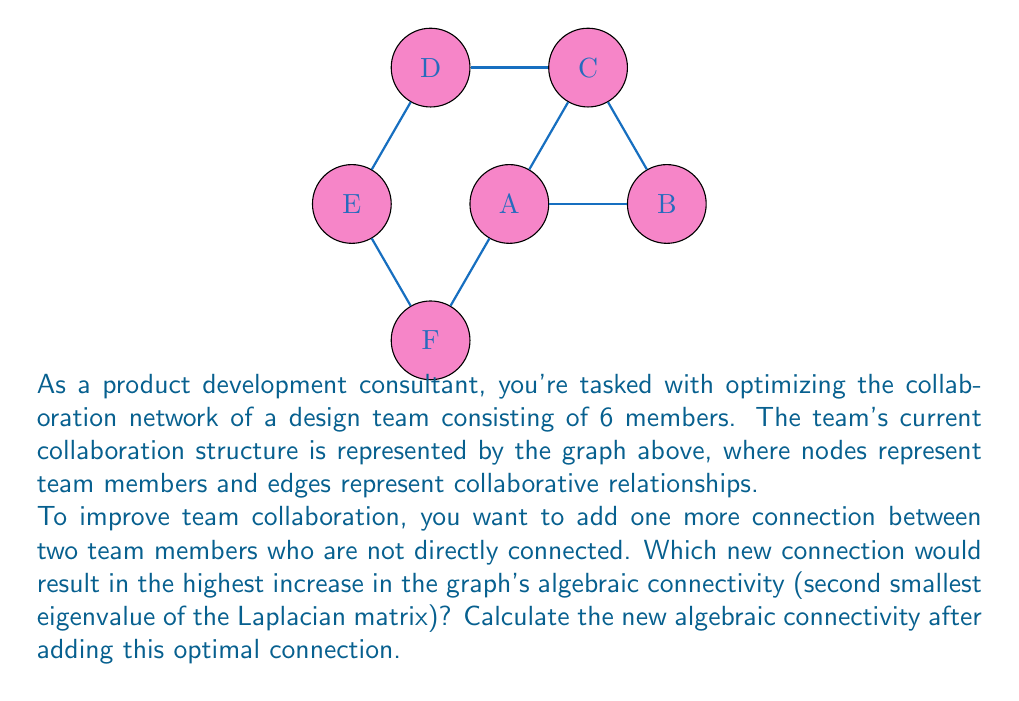Give your solution to this math problem. To solve this problem, we need to follow these steps:

1) First, we need to construct the Laplacian matrix of the current graph.
2) Then, we'll calculate its current algebraic connectivity.
3) We'll consider all possible new connections and calculate the resulting algebraic connectivity for each.
4) Finally, we'll choose the connection that gives the highest increase.

Step 1: Construct the Laplacian matrix

The Laplacian matrix $L$ is defined as $L = D - A$, where $D$ is the degree matrix and $A$ is the adjacency matrix.

For the given graph:

$$L = \begin{bmatrix}
3 & -1 & -1 & 0 & 0 & -1 \\
-1 & 2 & -1 & 0 & 0 & 0 \\
-1 & -1 & 3 & -1 & 0 & 0 \\
0 & 0 & -1 & 2 & -1 & 0 \\
0 & 0 & 0 & -1 & 2 & -1 \\
-1 & 0 & 0 & 0 & -1 & 2
\end{bmatrix}$$

Step 2: Calculate current algebraic connectivity

The eigenvalues of $L$ are approximately:
$\{0, 0.5858, 1.0000, 3.0000, 3.4142, 4.0000\}$

The algebraic connectivity is the second smallest eigenvalue: $0.5858$

Step 3: Consider all possible new connections

There are 7 possible new connections: AB, AD, AE, BD, BE, BF, and CE.
For each, we need to recalculate the Laplacian matrix and its eigenvalues.

After calculations, we find:
- AB: 0.7639
- AD: 0.8038
- AE: 0.7639
- BD: 0.7639
- BE: 0.7639
- BF: 0.7639
- CE: 0.8038

Step 4: Choose the optimal connection

The highest increase in algebraic connectivity is achieved by adding either AD or CE, both resulting in a new algebraic connectivity of 0.8038.
Answer: AD or CE; 0.8038 